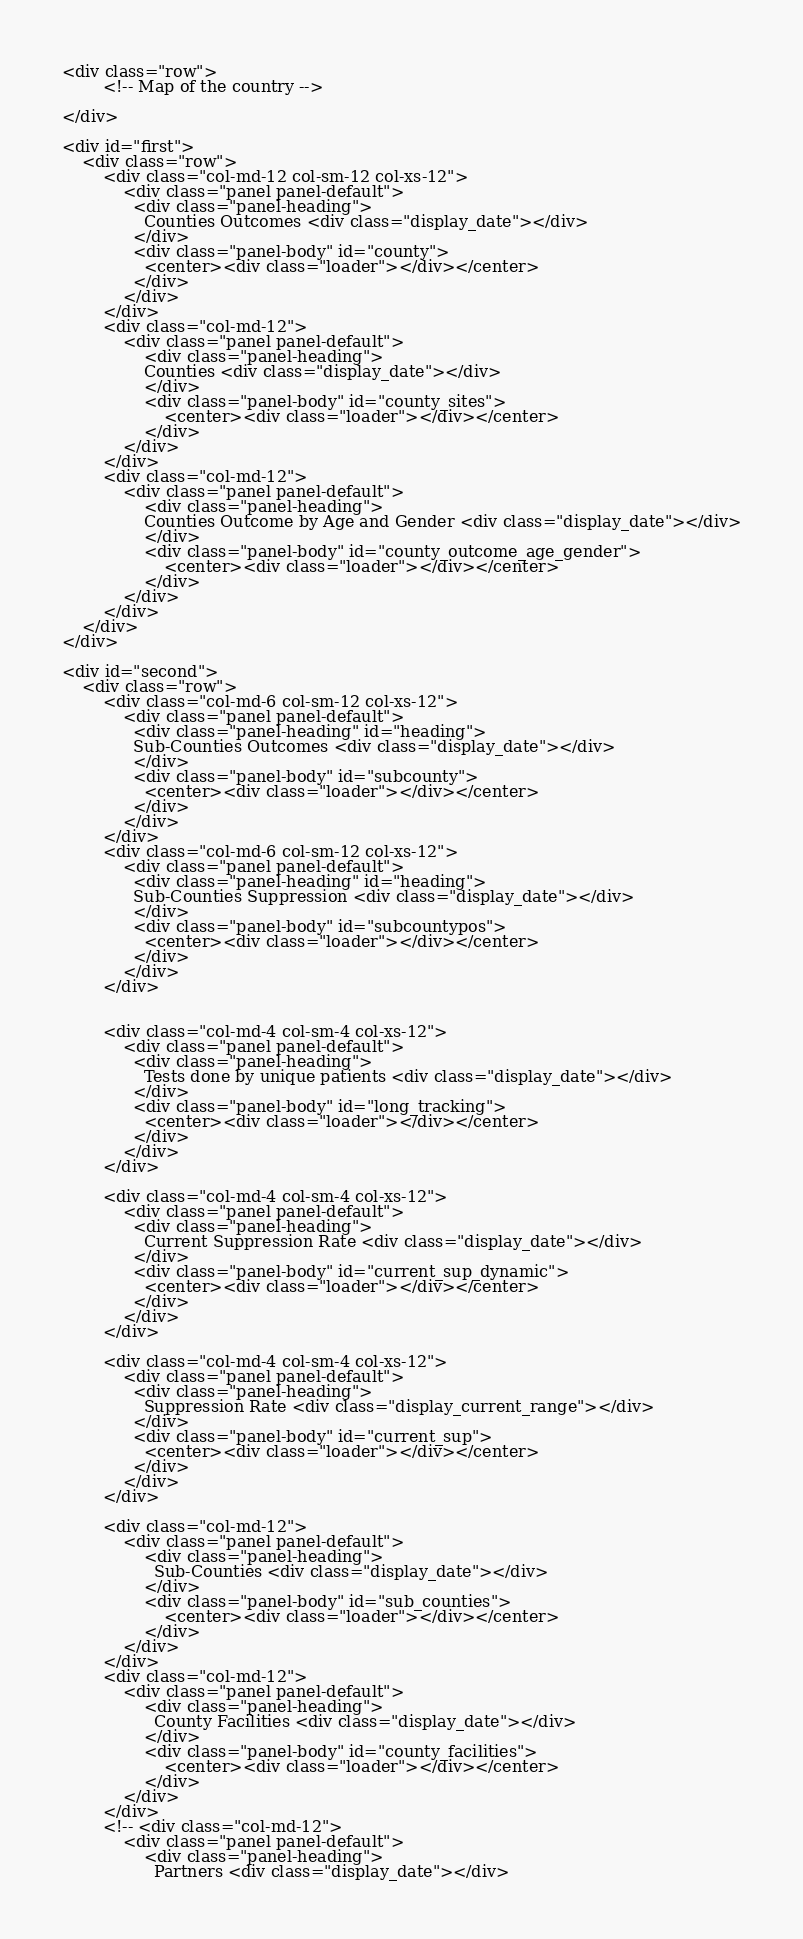Convert code to text. <code><loc_0><loc_0><loc_500><loc_500><_PHP_><div class="row">
		<!-- Map of the country -->
	
</div>

<div id="first">
	<div class="row">
		<div class="col-md-12 col-sm-12 col-xs-12">
			<div class="panel panel-default">
			  <div class="panel-heading">
			  	Counties Outcomes <div class="display_date"></div>
			  </div>
			  <div class="panel-body" id="county">
			    <center><div class="loader"></div></center>
			  </div>
			</div>
		</div>
		<div class="col-md-12">
			<div class="panel panel-default">
				<div class="panel-heading">
				Counties <div class="display_date"></div>
				</div>
			  	<div class="panel-body" id="county_sites">
			  		<center><div class="loader"></div></center>
			  	</div>
			</div>
		</div>
		<div class="col-md-12">
			<div class="panel panel-default">
				<div class="panel-heading">
				Counties Outcome by Age and Gender <div class="display_date"></div>
				</div>
			  	<div class="panel-body" id="county_outcome_age_gender">
			  		<center><div class="loader"></div></center>
			  	</div>
			</div>
		</div>
	</div>
</div>

<div id="second">
	<div class="row">
		<div class="col-md-6 col-sm-12 col-xs-12">
			<div class="panel panel-default">
			  <div class="panel-heading" id="heading">
			  Sub-Counties Outcomes <div class="display_date"></div>
			  </div>
			  <div class="panel-body" id="subcounty">
			    <center><div class="loader"></div></center>
			  </div>
			</div>
		</div>
		<div class="col-md-6 col-sm-12 col-xs-12">
			<div class="panel panel-default">
			  <div class="panel-heading" id="heading">
			  Sub-Counties Suppression <div class="display_date"></div>
			  </div>
			  <div class="panel-body" id="subcountypos">
			    <center><div class="loader"></div></center>
			  </div>
			</div>
		</div>


		<div class="col-md-4 col-sm-4 col-xs-12">
			<div class="panel panel-default">
			  <div class="panel-heading">
			    Tests done by unique patients <div class="display_date"></div>
			  </div>
			  <div class="panel-body" id="long_tracking">
			    <center><div class="loader"></div></center>
			  </div>
			</div>
		</div>

		<div class="col-md-4 col-sm-4 col-xs-12">
			<div class="panel panel-default">
			  <div class="panel-heading">
			    Current Suppression Rate <div class="display_date"></div>
			  </div>
			  <div class="panel-body" id="current_sup_dynamic">
			    <center><div class="loader"></div></center>
			  </div>
			</div>
		</div>

		<div class="col-md-4 col-sm-4 col-xs-12">
			<div class="panel panel-default">
			  <div class="panel-heading">
			    Suppression Rate <div class="display_current_range"></div>
			  </div>
			  <div class="panel-body" id="current_sup">
			    <center><div class="loader"></div></center>
			  </div>
			</div>
		</div>
	
		<div class="col-md-12">
			<div class="panel panel-default">
				<div class="panel-heading">
				  Sub-Counties <div class="display_date"></div>
				</div>
			  	<div class="panel-body" id="sub_counties">
			  		<center><div class="loader"></div></center>
			  	</div>
			</div>
		</div>
		<div class="col-md-12">
			<div class="panel panel-default">
				<div class="panel-heading">
				  County Facilities <div class="display_date"></div>
				</div>
			  	<div class="panel-body" id="county_facilities">
			  		<center><div class="loader"></div></center>
			  	</div>
			</div>
		</div>
		<!-- <div class="col-md-12">
			<div class="panel panel-default">
				<div class="panel-heading">
				  Partners <div class="display_date"></div></code> 